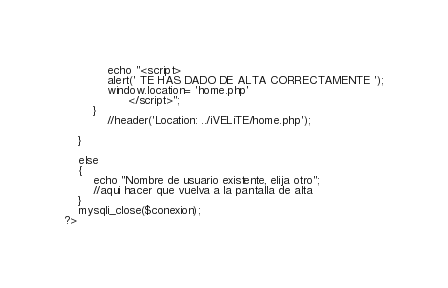<code> <loc_0><loc_0><loc_500><loc_500><_PHP_>			echo "<script>
			alert('	TE HAS DADO DE ALTA CORRECTAMENTE ');
			window.location= 'home.php'
				  </script>";
		}
			//header('Location: ../iVELiTE/home.php'); 
		
    }
	
	else 
	{
		echo "Nombre de usuario existente, elija otro";
		//aqui hacer que vuelva a la pantalla de alta
	}
	mysqli_close($conexion);
?>	</code> 